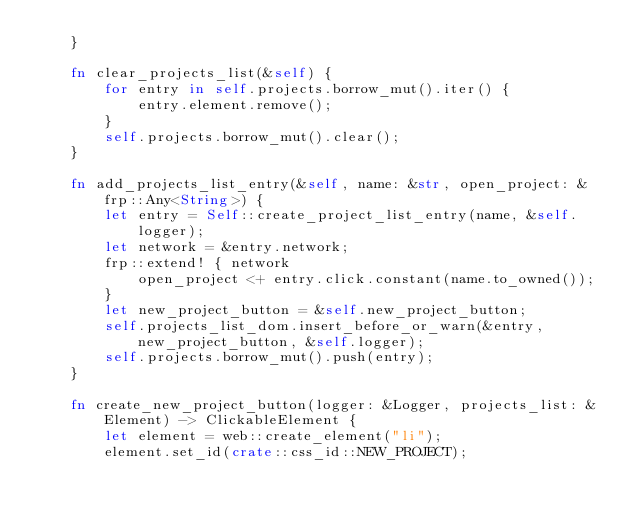Convert code to text. <code><loc_0><loc_0><loc_500><loc_500><_Rust_>    }

    fn clear_projects_list(&self) {
        for entry in self.projects.borrow_mut().iter() {
            entry.element.remove();
        }
        self.projects.borrow_mut().clear();
    }

    fn add_projects_list_entry(&self, name: &str, open_project: &frp::Any<String>) {
        let entry = Self::create_project_list_entry(name, &self.logger);
        let network = &entry.network;
        frp::extend! { network
            open_project <+ entry.click.constant(name.to_owned());
        }
        let new_project_button = &self.new_project_button;
        self.projects_list_dom.insert_before_or_warn(&entry, new_project_button, &self.logger);
        self.projects.borrow_mut().push(entry);
    }

    fn create_new_project_button(logger: &Logger, projects_list: &Element) -> ClickableElement {
        let element = web::create_element("li");
        element.set_id(crate::css_id::NEW_PROJECT);</code> 